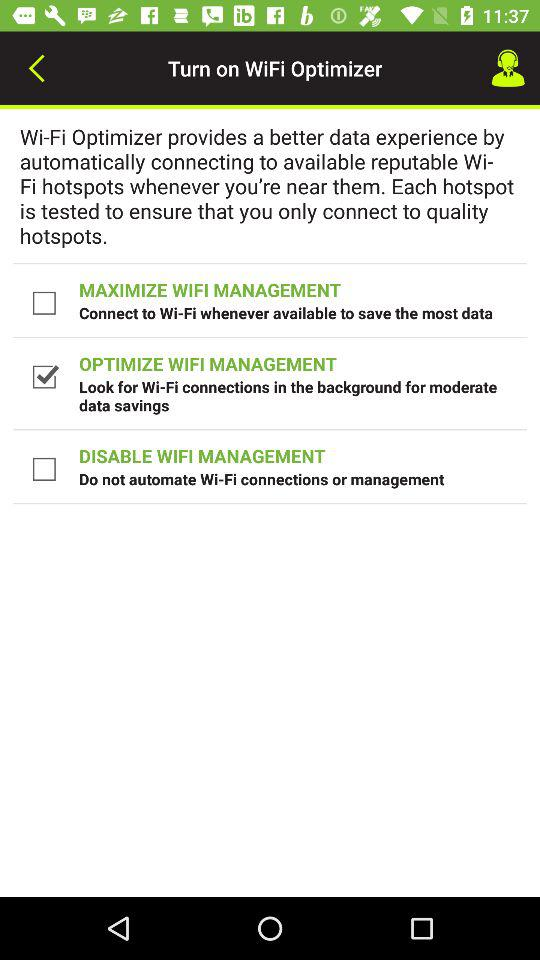What is the current status of "MAXIMIZE WIFI MANAGEMENT"? The current status is "off". 